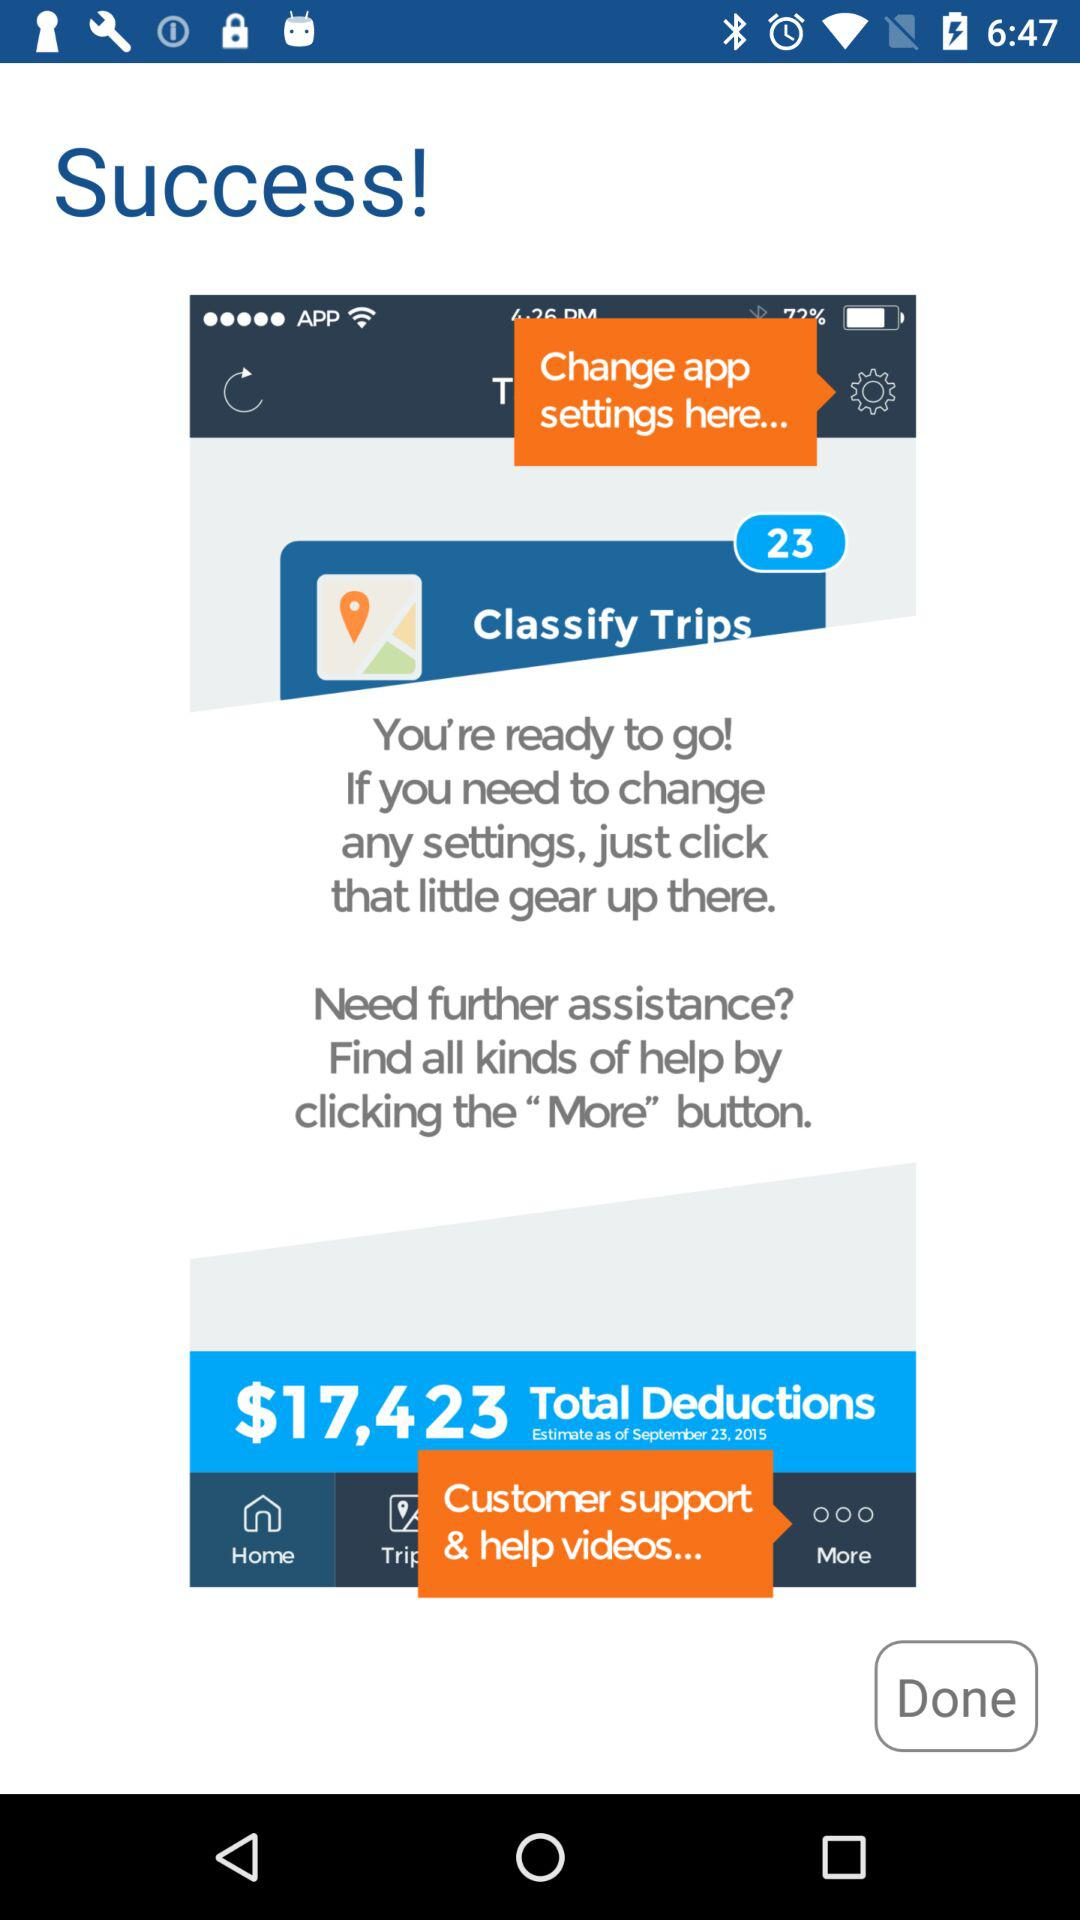What is the selected tab? The selected tab is "Home". 